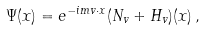<formula> <loc_0><loc_0><loc_500><loc_500>\Psi ( x ) = e ^ { - i m v \cdot x } ( N _ { v } + H _ { v } ) ( x ) \, ,</formula> 